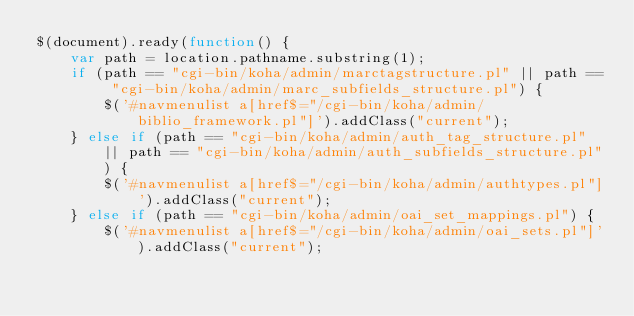<code> <loc_0><loc_0><loc_500><loc_500><_JavaScript_>$(document).ready(function() {
    var path = location.pathname.substring(1);
    if (path == "cgi-bin/koha/admin/marctagstructure.pl" || path == "cgi-bin/koha/admin/marc_subfields_structure.pl") {
        $('#navmenulist a[href$="/cgi-bin/koha/admin/biblio_framework.pl"]').addClass("current");
    } else if (path == "cgi-bin/koha/admin/auth_tag_structure.pl" || path == "cgi-bin/koha/admin/auth_subfields_structure.pl") {
        $('#navmenulist a[href$="/cgi-bin/koha/admin/authtypes.pl"]').addClass("current");
    } else if (path == "cgi-bin/koha/admin/oai_set_mappings.pl") {
        $('#navmenulist a[href$="/cgi-bin/koha/admin/oai_sets.pl"]').addClass("current");</code> 